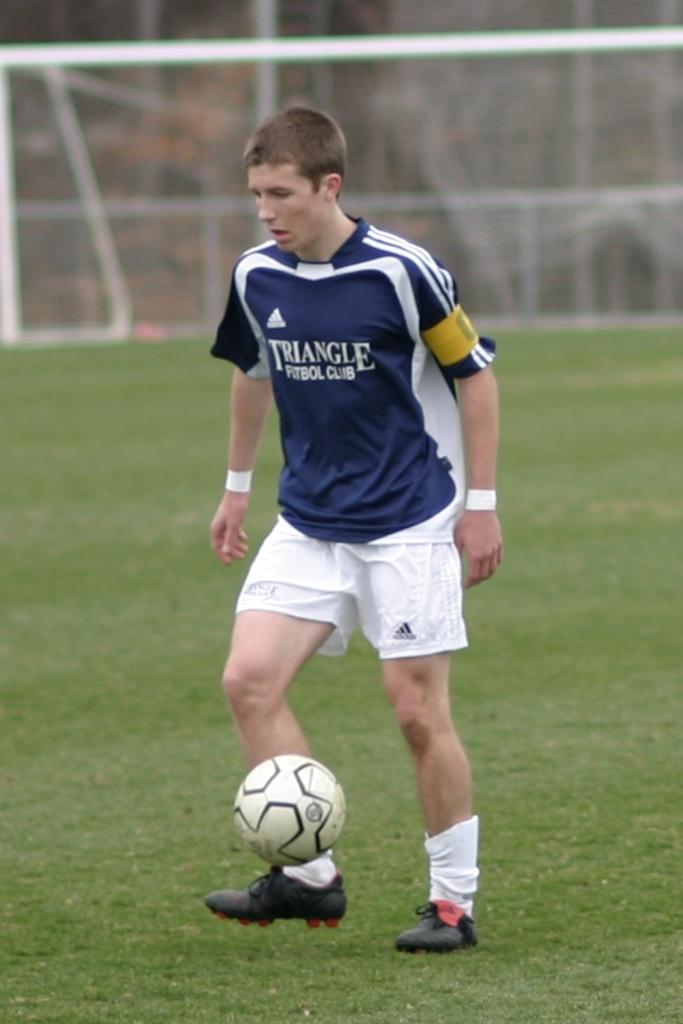<image>
Summarize the visual content of the image. Young man playing soccer with a blue and white Triangle shirt. 